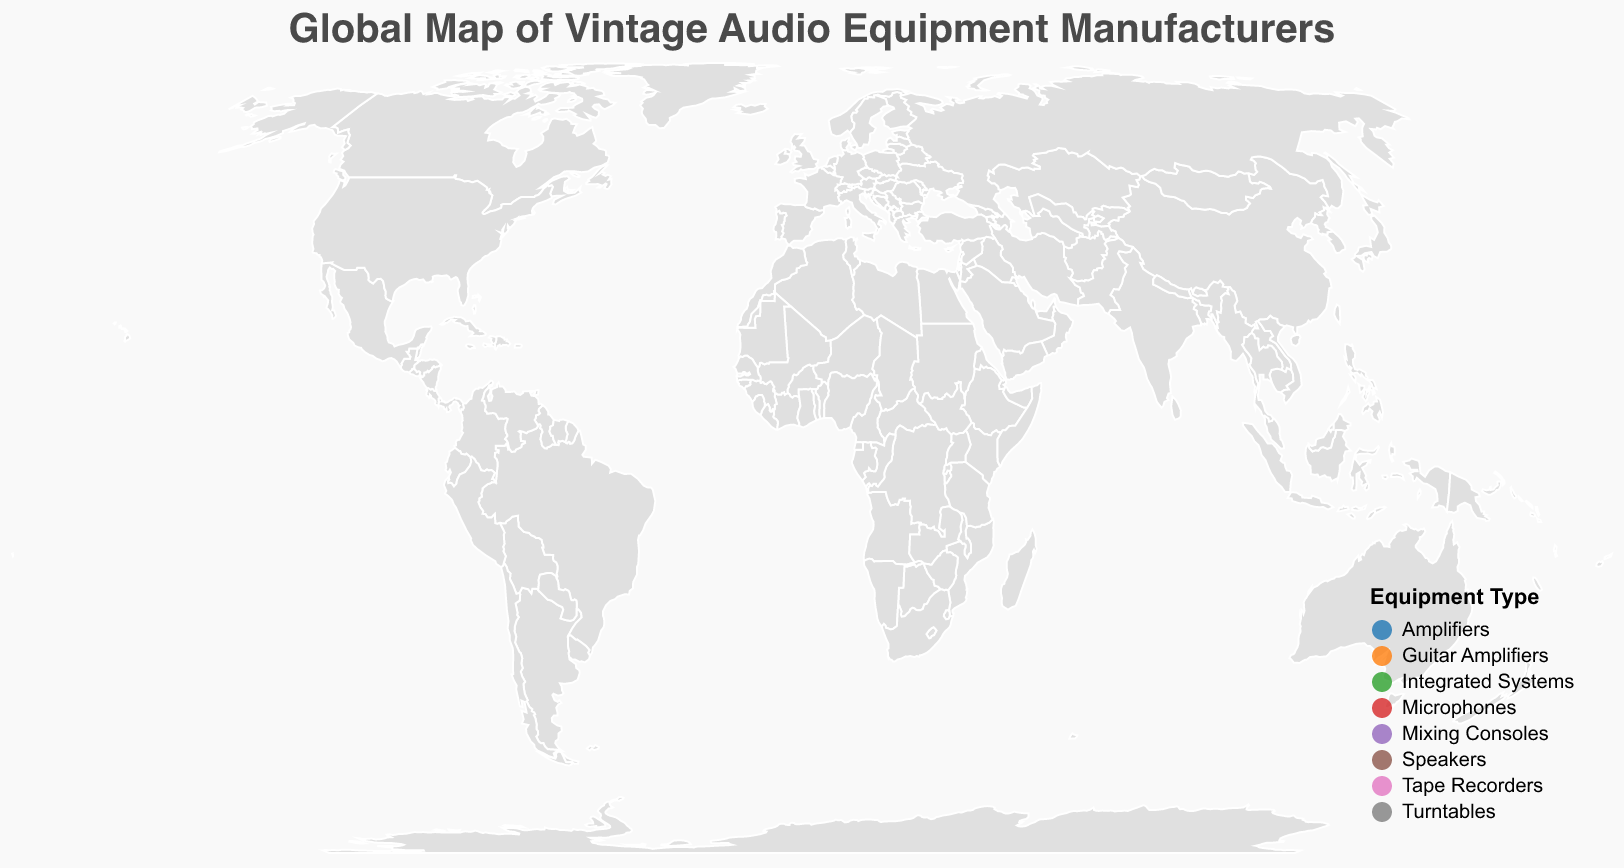What is the title of the figure? The title is displayed at the top of the figure and is "Global Map of Vintage Audio Equipment Manufacturers".
Answer: Global Map of Vintage Audio Equipment Manufacturers Which two countries have the highest Vintage Scores and which companies are they associated with? From the figure, the highest Vintage Scores of 10 and 9 are visually represented by larger circles. Germany (Telefunken) has a score of 10, and multiple countries have companies with a Vintage Score of 9: the United States (McIntosh Laboratory), United Kingdom (Linn Products), and Switzerland (Studer).
Answer: Germany (Telefunken) and the United States, United Kingdom, and Switzerland (McIntosh Laboratory, Linn Products, Studer) What type of equipment is made by the company located in Sweden and what is its Vintage Score? By examining the tooltip information connected to the circle over Sweden, it shows Hagström, which makes Guitar Amplifiers with a Vintage Score of 7.
Answer: Guitar Amplifiers, 7 How many manufacturers on the map specialize in Speakers, and in which countries are they located? By looking at the color legend for "Speakers" and identifying relevant points on the map, there are three companies: Philips in the Netherlands, Sonus Faber in Italy, and Cabasse in France.
Answer: Three manufacturers: Netherlands, Italy, France What is the range of Vintage Scores for microphone manufacturers? By reviewing the specific equipment type and the corresponding Vintage Scores on the map, Telefunken in Germany has a score of 10 and Oktava in Russia has a score of 8, giving a range from 8 to 10.
Answer: 8 to 10 Which country has the westernmost manufacturer and what company is it? The westernmost point can be identified on the geographic plot, which refers to the circle furthest to the left. This manufacturer is located in the United States, and the company is McIntosh Laboratory.
Answer: United States, McIntosh Laboratory Compare the Vintage Scores of Amplifier manufacturers from the United States, Canada, and Australia. Which country has the highest score? The Vintage Scores for Amplifiers (identified by size of circles) are as follows: United States (9), Canada (8), and Australia (7). The highest score is in the United States.
Answer: United States Which company's equipment type is the most unique in terms of concentration on the map and where is it located? Based on the map legend and the tooltips, Studer in Switzerland produces Mixing Consoles, which is unique in comparison to other more frequently occurring types like Speakers or Amplifiers.
Answer: Studer, Switzerland What is the median Vintage Score for all manufacturers shown on the map? First, we list all the Vintage Scores: 9, 8, 9, 10, 9, 7, 8, 8, 7, 8, 7, 8, 7. We then sort them: 7, 7, 7, 7, 8, 8, 8, 8, 8, 9, 9, 9, 10. The median score, being the middle value in the sorted list, is 8.
Answer: 8 